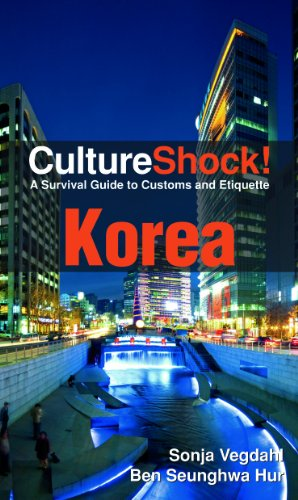Could you describe a key custom or etiquette from Korea mentioned in this book? One key etiquette described in the book is the importance of age hierarchy in Korean culture, emphasizing respect for elders in both social and professional settings. How can travelers apply this custom effectively? Travelers can apply this by using proper titles instead of names when addressing elders and waiting for elders to extend their hand first for a handshake, demonstrating respect and understanding of their customs. 